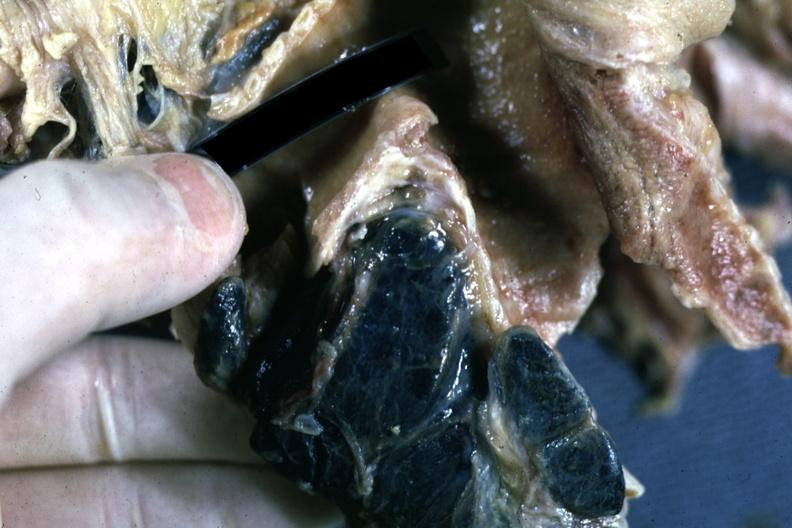what sectioned carinal nodes shown close-up nodes are filled with black pigment?
Answer the question using a single word or phrase. Fixed tissue 